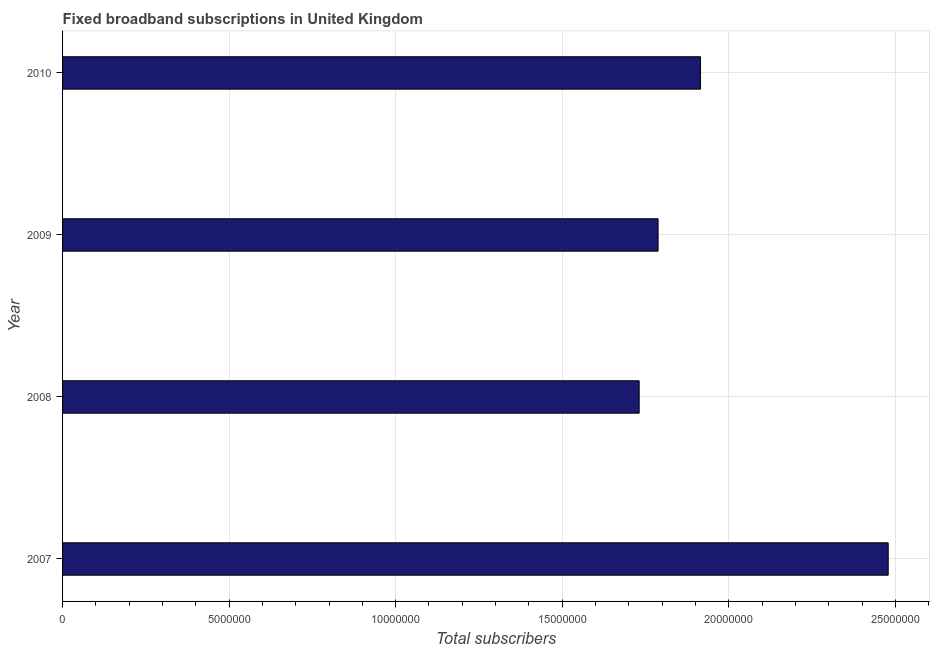Does the graph contain any zero values?
Your answer should be compact. No. What is the title of the graph?
Provide a succinct answer. Fixed broadband subscriptions in United Kingdom. What is the label or title of the X-axis?
Your answer should be compact. Total subscribers. What is the label or title of the Y-axis?
Keep it short and to the point. Year. What is the total number of fixed broadband subscriptions in 2007?
Your answer should be very brief. 2.48e+07. Across all years, what is the maximum total number of fixed broadband subscriptions?
Ensure brevity in your answer.  2.48e+07. Across all years, what is the minimum total number of fixed broadband subscriptions?
Your answer should be very brief. 1.73e+07. What is the sum of the total number of fixed broadband subscriptions?
Provide a short and direct response. 7.91e+07. What is the difference between the total number of fixed broadband subscriptions in 2007 and 2008?
Make the answer very short. 7.48e+06. What is the average total number of fixed broadband subscriptions per year?
Give a very brief answer. 1.98e+07. What is the median total number of fixed broadband subscriptions?
Provide a short and direct response. 1.85e+07. What is the ratio of the total number of fixed broadband subscriptions in 2008 to that in 2010?
Your response must be concise. 0.9. Is the total number of fixed broadband subscriptions in 2009 less than that in 2010?
Provide a short and direct response. Yes. Is the difference between the total number of fixed broadband subscriptions in 2009 and 2010 greater than the difference between any two years?
Offer a terse response. No. What is the difference between the highest and the second highest total number of fixed broadband subscriptions?
Make the answer very short. 5.63e+06. Is the sum of the total number of fixed broadband subscriptions in 2008 and 2009 greater than the maximum total number of fixed broadband subscriptions across all years?
Offer a terse response. Yes. What is the difference between the highest and the lowest total number of fixed broadband subscriptions?
Your answer should be compact. 7.48e+06. Are all the bars in the graph horizontal?
Provide a short and direct response. Yes. What is the Total subscribers in 2007?
Give a very brief answer. 2.48e+07. What is the Total subscribers of 2008?
Provide a succinct answer. 1.73e+07. What is the Total subscribers of 2009?
Provide a short and direct response. 1.79e+07. What is the Total subscribers of 2010?
Offer a very short reply. 1.92e+07. What is the difference between the Total subscribers in 2007 and 2008?
Ensure brevity in your answer.  7.48e+06. What is the difference between the Total subscribers in 2007 and 2009?
Your answer should be compact. 6.91e+06. What is the difference between the Total subscribers in 2007 and 2010?
Give a very brief answer. 5.63e+06. What is the difference between the Total subscribers in 2008 and 2009?
Your response must be concise. -5.67e+05. What is the difference between the Total subscribers in 2008 and 2010?
Offer a very short reply. -1.84e+06. What is the difference between the Total subscribers in 2009 and 2010?
Make the answer very short. -1.27e+06. What is the ratio of the Total subscribers in 2007 to that in 2008?
Offer a terse response. 1.43. What is the ratio of the Total subscribers in 2007 to that in 2009?
Offer a terse response. 1.39. What is the ratio of the Total subscribers in 2007 to that in 2010?
Offer a very short reply. 1.29. What is the ratio of the Total subscribers in 2008 to that in 2009?
Give a very brief answer. 0.97. What is the ratio of the Total subscribers in 2008 to that in 2010?
Ensure brevity in your answer.  0.9. What is the ratio of the Total subscribers in 2009 to that in 2010?
Provide a succinct answer. 0.93. 